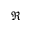<formula> <loc_0><loc_0><loc_500><loc_500>\Re</formula> 